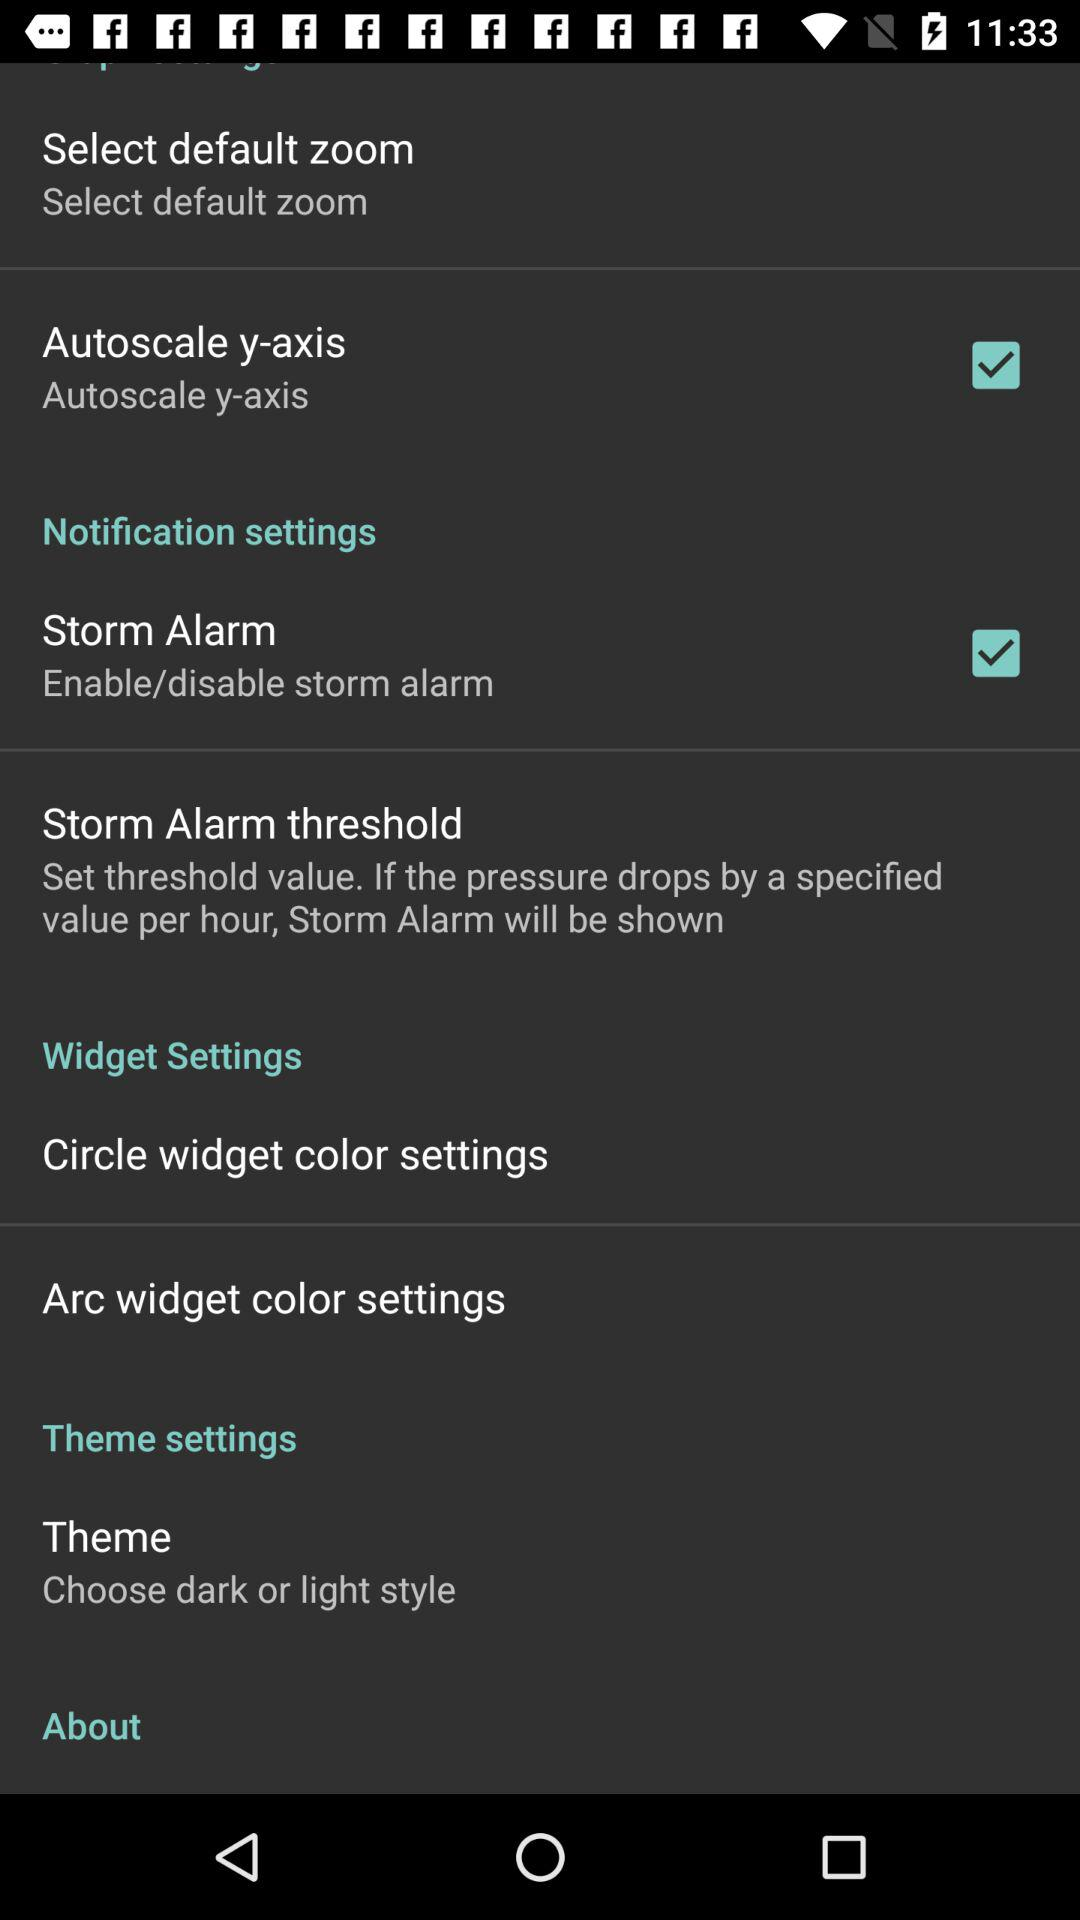What is the status of the "Autoscale y-axis"? The status is on. 